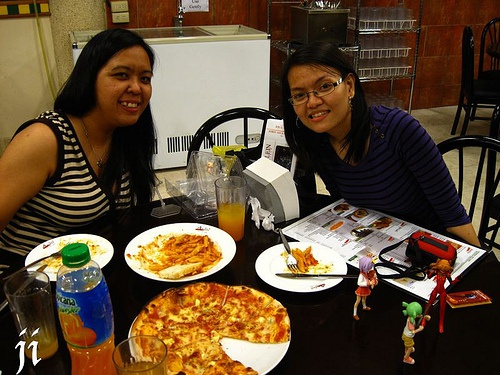Describe the objects in this image and their specific colors. I can see people in black, maroon, and brown tones, dining table in black, gray, and maroon tones, people in black, maroon, and brown tones, pizza in black, orange, red, and brown tones, and bottle in black, navy, maroon, brown, and gray tones in this image. 